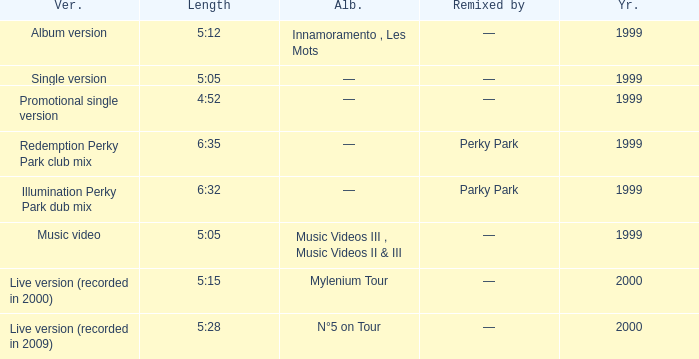Parse the table in full. {'header': ['Ver.', 'Length', 'Alb.', 'Remixed by', 'Yr.'], 'rows': [['Album version', '5:12', 'Innamoramento , Les Mots', '—', '1999'], ['Single version', '5:05', '—', '—', '1999'], ['Promotional single version', '4:52', '—', '—', '1999'], ['Redemption Perky Park club mix', '6:35', '—', 'Perky Park', '1999'], ['Illumination Perky Park dub mix', '6:32', '—', 'Parky Park', '1999'], ['Music video', '5:05', 'Music Videos III , Music Videos II & III', '—', '1999'], ['Live version (recorded in 2000)', '5:15', 'Mylenium Tour', '—', '2000'], ['Live version (recorded in 2009)', '5:28', 'N°5 on Tour', '—', '2000']]} What album is 5:15 long Live version (recorded in 2000). 